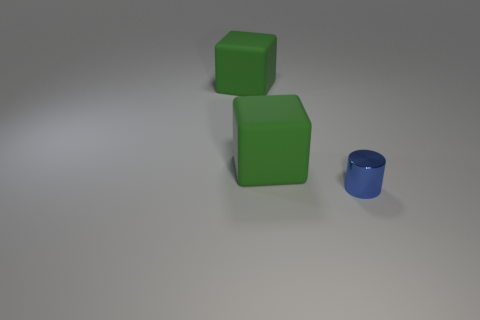Is there any other thing that has the same material as the blue cylinder?
Offer a very short reply. No. What number of objects are tiny blue metal cylinders or things that are behind the tiny blue shiny object?
Make the answer very short. 3. Is the number of big blocks to the left of the blue shiny cylinder greater than the number of small red objects?
Give a very brief answer. Yes. What shape is the small blue thing?
Your answer should be compact. Cylinder. What is the color of the tiny cylinder?
Make the answer very short. Blue. Are there any balls that have the same color as the tiny metal cylinder?
Your answer should be very brief. No. What number of brown objects are big matte cubes or shiny cylinders?
Provide a succinct answer. 0. What number of objects are to the left of the small cylinder?
Provide a short and direct response. 2. What number of cubes are either small blue metal objects or big red metallic objects?
Provide a succinct answer. 0. Are there any other small cylinders that have the same material as the cylinder?
Offer a terse response. No. 